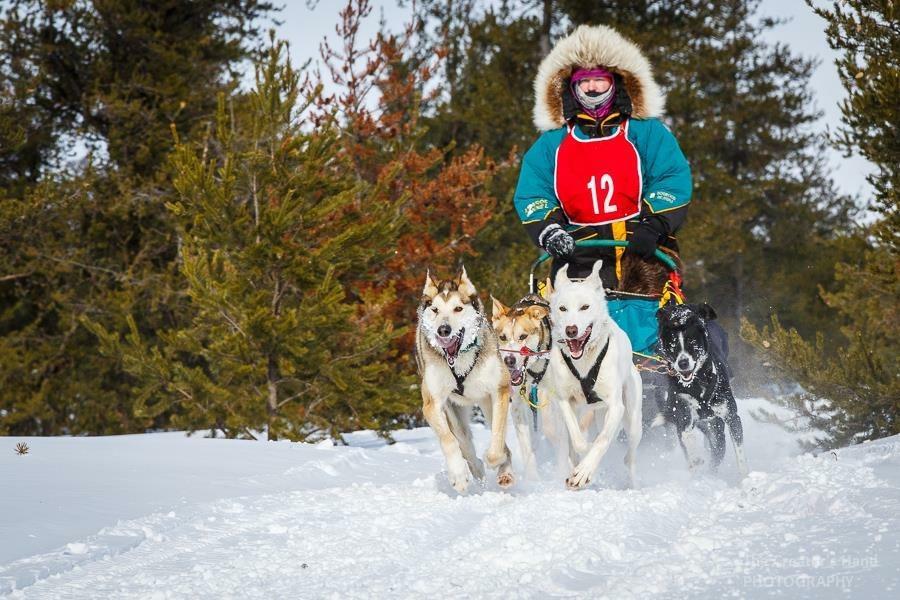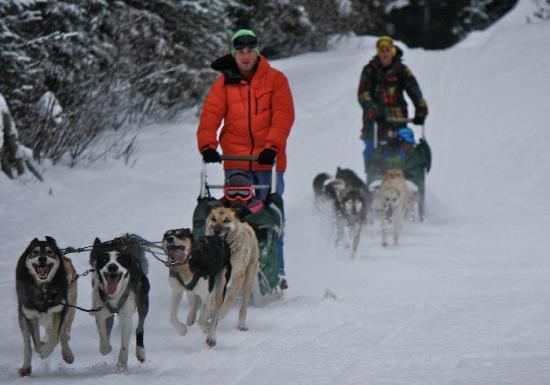The first image is the image on the left, the second image is the image on the right. Examine the images to the left and right. Is the description "Both images show at least one sled pulled by no more than five dogs." accurate? Answer yes or no. Yes. The first image is the image on the left, the second image is the image on the right. For the images shown, is this caption "The combined images contain three teams of sled dogs running forward across the snow instead of away from the camera." true? Answer yes or no. Yes. 